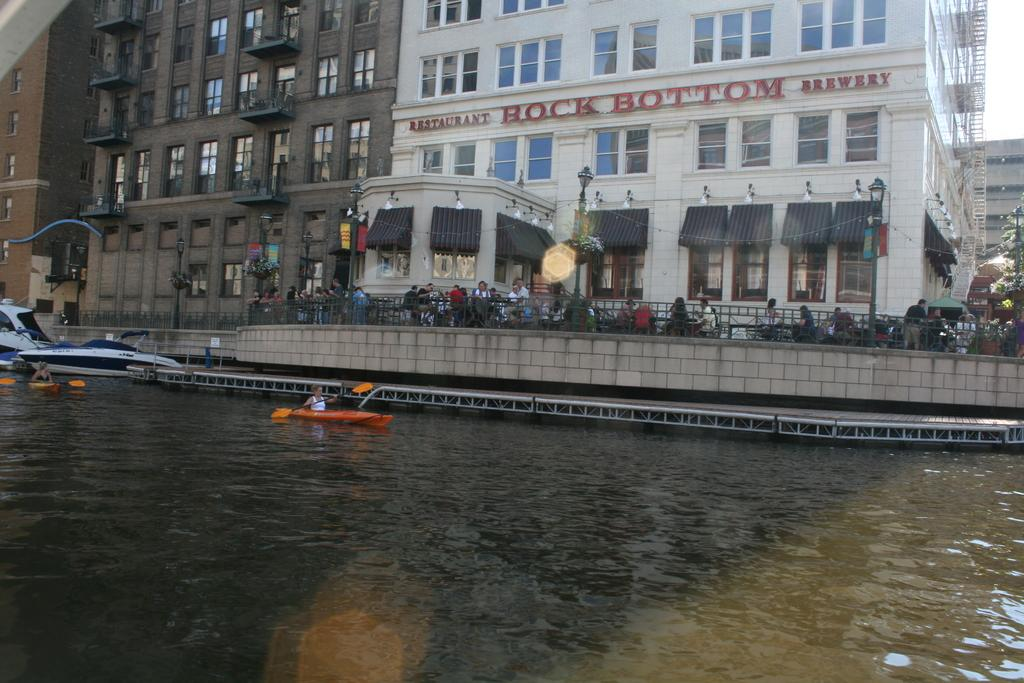What is happening on the water in the image? There are boats on the water in the image. What can be seen in the background of the image? There are buildings visible in the image. What are the people in the image doing? There are people sitting on chairs in the image. Can you see a gate in the image? There is no gate present in the image. Is there a kite flying in the sky in the image? There is no kite visible in the image. 